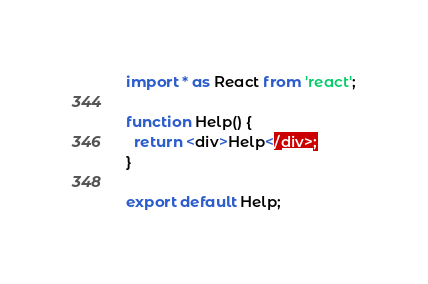<code> <loc_0><loc_0><loc_500><loc_500><_TypeScript_>import * as React from 'react';

function Help() {
  return <div>Help</div>;
}

export default Help;
</code> 